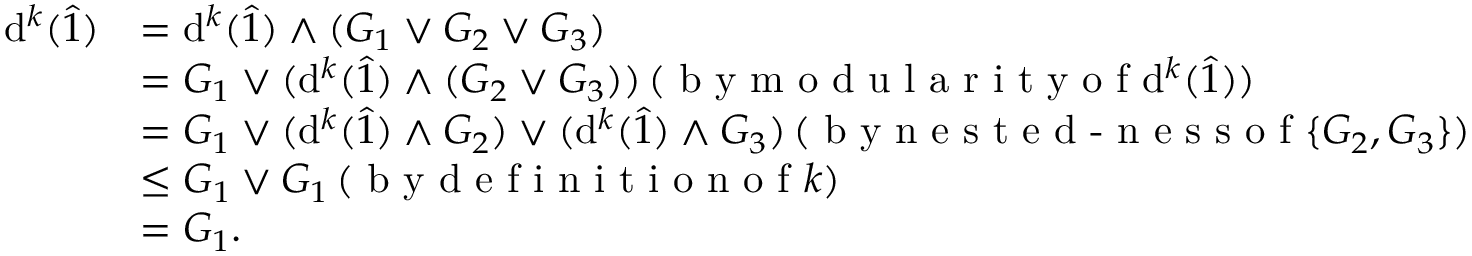Convert formula to latex. <formula><loc_0><loc_0><loc_500><loc_500>\begin{array} { r l } { d ^ { k } ( \hat { 1 } ) } & { = d ^ { k } ( \hat { 1 } ) \wedge ( G _ { 1 } \vee G _ { 2 } \vee G _ { 3 } ) } \\ & { = G _ { 1 } \vee ( d ^ { k } ( \hat { 1 } ) \wedge ( G _ { 2 } \vee G _ { 3 } ) ) \, ( b y m o d u l a r i t y o f d ^ { k } ( \hat { 1 } ) ) } \\ & { = G _ { 1 } \vee ( d ^ { k } ( \hat { 1 } ) \wedge G _ { 2 } ) \vee ( d ^ { k } ( \hat { 1 } ) \wedge G _ { 3 } ) \, ( b y n e s t e d - n e s s o f \{ G _ { 2 } , G _ { 3 } \} ) } \\ & { \leq G _ { 1 } \vee G _ { 1 } \, ( b y d e f i n i t i o n o f k ) } \\ & { = G _ { 1 } . } \end{array}</formula> 